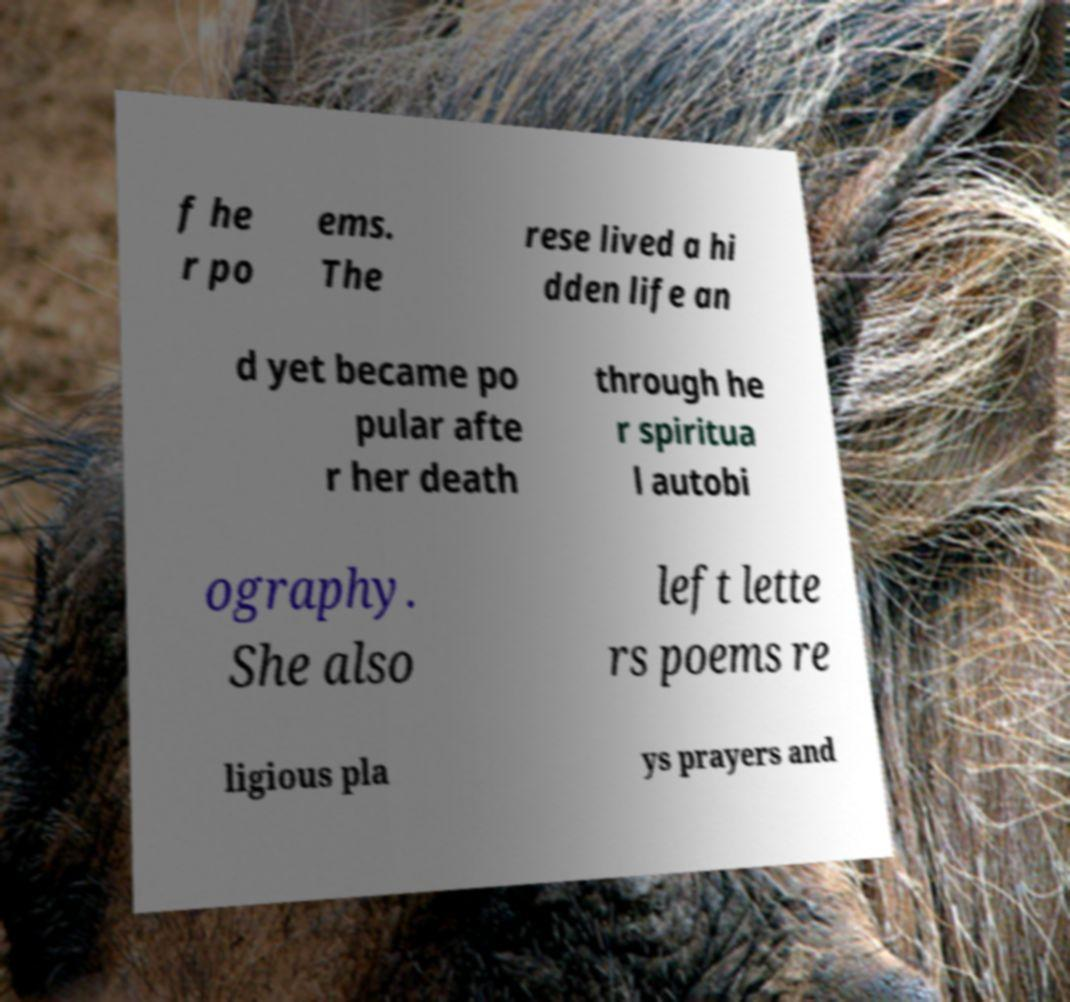Could you assist in decoding the text presented in this image and type it out clearly? f he r po ems. The rese lived a hi dden life an d yet became po pular afte r her death through he r spiritua l autobi ography. She also left lette rs poems re ligious pla ys prayers and 